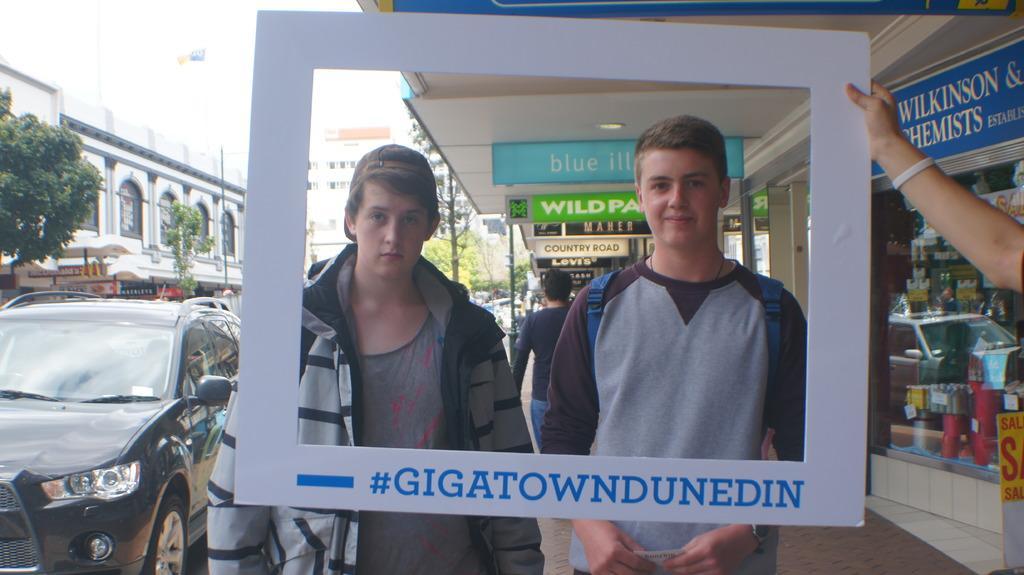Can you describe this image briefly? In this picture I can observe two boys. One of them is wearing a jacket. In front of them there is a white color frame. On the left side there is a black color car on the road. In the background there are trees and buildings. I can observe a sky. 